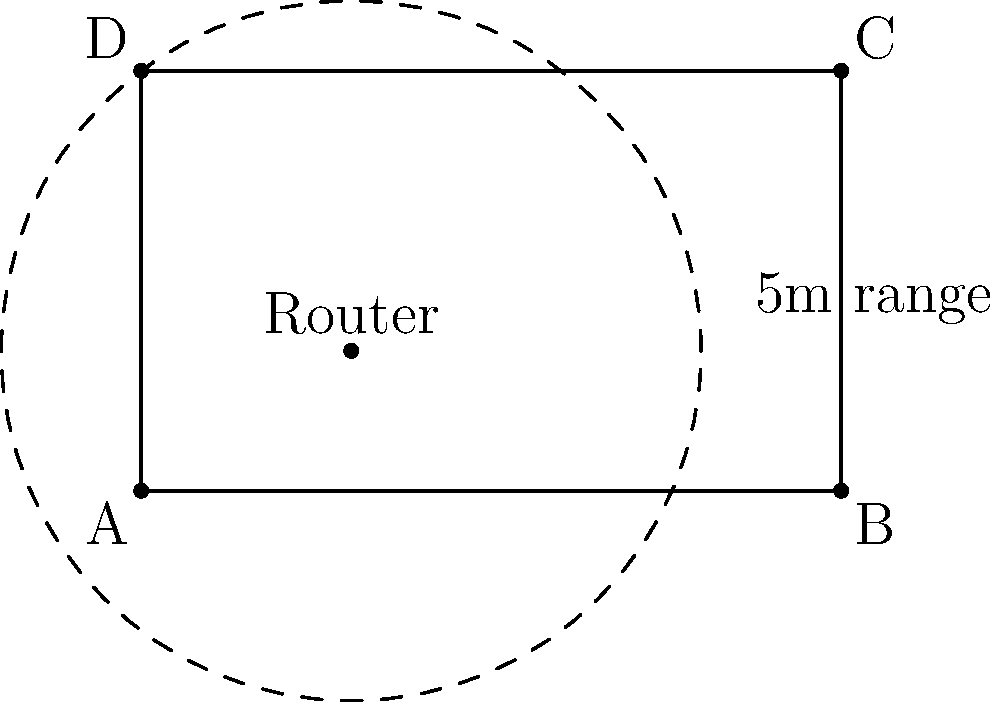A smart home company is testing Bluetooth connectivity in a rectangular room measuring 10m by 6m. A Bluetooth router is placed at coordinates (3m, 2m) from the bottom-left corner of the room. If the Bluetooth signal has a range of 5m, what is the total area of the room covered by the signal? Round your answer to the nearest square meter. To solve this problem, we need to follow these steps:

1) The room is a rectangle, so its total area is:
   $A_{room} = 10m \times 6m = 60m^2$

2) The Bluetooth signal forms a circle with radius 5m. The area of this circle is:
   $A_{circle} = \pi r^2 = \pi \times 5^2 = 25\pi m^2$

3) However, parts of this circle may extend beyond the room's boundaries. We need to determine the area of the circle that's within the room.

4) To do this, we can divide the problem into four cases:
   a) The circle is completely inside the room
   b) The circle intersects with one wall
   c) The circle intersects with two walls (corner)
   d) The circle intersects with three or four walls

5) In this case, the circle intersects with two walls (left and bottom).

6) To calculate the area, we can:
   - Find the area of the full circle: $25\pi m^2$
   - Subtract the areas of the circular segments outside the room

7) The areas of these segments can be calculated using the formula:
   $A_{segment} = r^2 \arccos(\frac{d}{r}) - d\sqrt{r^2 - d^2}$
   where $d$ is the distance from the center to the chord (wall in this case)

8) For the left wall: $d_1 = 3m$
   $A_{segment1} = 5^2 \arccos(\frac{3}{5}) - 3\sqrt{5^2 - 3^2} \approx 5.59m^2$

9) For the bottom wall: $d_2 = 2m$
   $A_{segment2} = 5^2 \arccos(\frac{2}{5}) - 2\sqrt{5^2 - 2^2} \approx 9.46m^2$

10) The total area covered is:
    $A_{covered} = 25\pi - 5.59 - 9.46 \approx 63.53m^2$

11) However, this exceeds the room area, so the actual covered area is the entire room: $60m^2$
Answer: 60 $m^2$ 